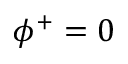Convert formula to latex. <formula><loc_0><loc_0><loc_500><loc_500>\phi ^ { + } = 0</formula> 